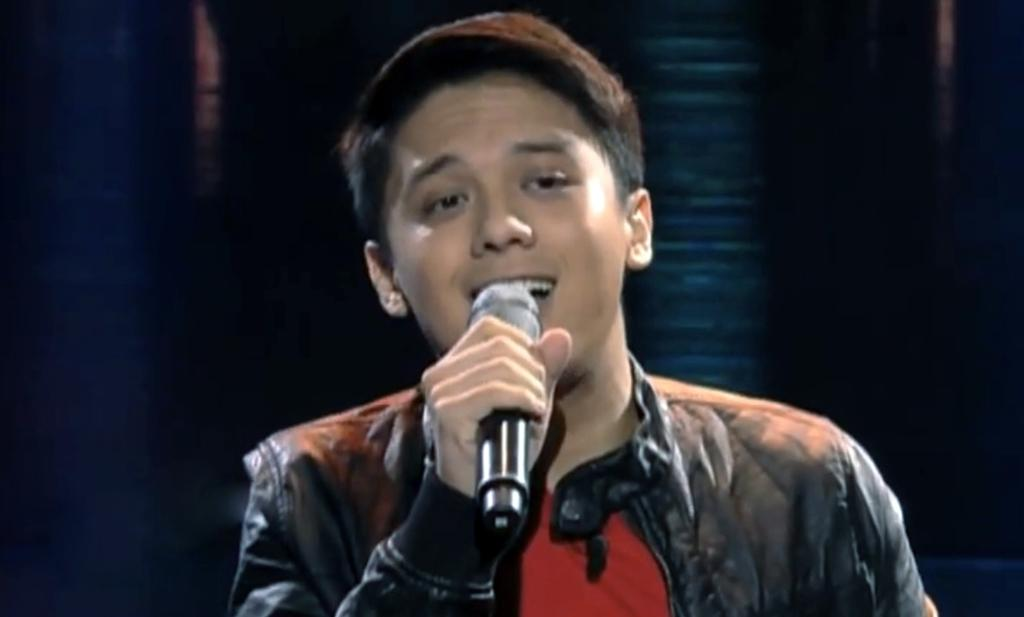What is the main subject of the image? There is a person in the image. What is the person wearing? The person is wearing a jacket. What object is the person holding? The person is holding a microphone. Can you describe the background of the image? The background of the image is dark. How many hands does the person have in the image? The person in the image has two hands, but we cannot determine the exact number of hands from the image alone. --- Facts: 1. There is a car in the image. 2. The car is red. 3. The car has four wheels. 4. There is a road in the image. 5. The road is paved. Absurd Topics: bird, ocean, mountain Conversation: What is the main subject of the image? There is a car in the image. What color is the car? The car is red. How many wheels does the car have? The car has four wheels. What type of surface is the car on? There is a road in the image, and it is paved. Reasoning: Let's think step by step in order to produce the conversation. We start by identifying the main subject of the image, which is the car. Then, we describe the car's color and the number of wheels it has, which are known from the provided facts. Finally, we mention the type of surface the car is on, which is a paved road. Absurd Question/Answer: Can you see any mountains in the image? There are no mountains visible in the image; it features a car on a paved road. 